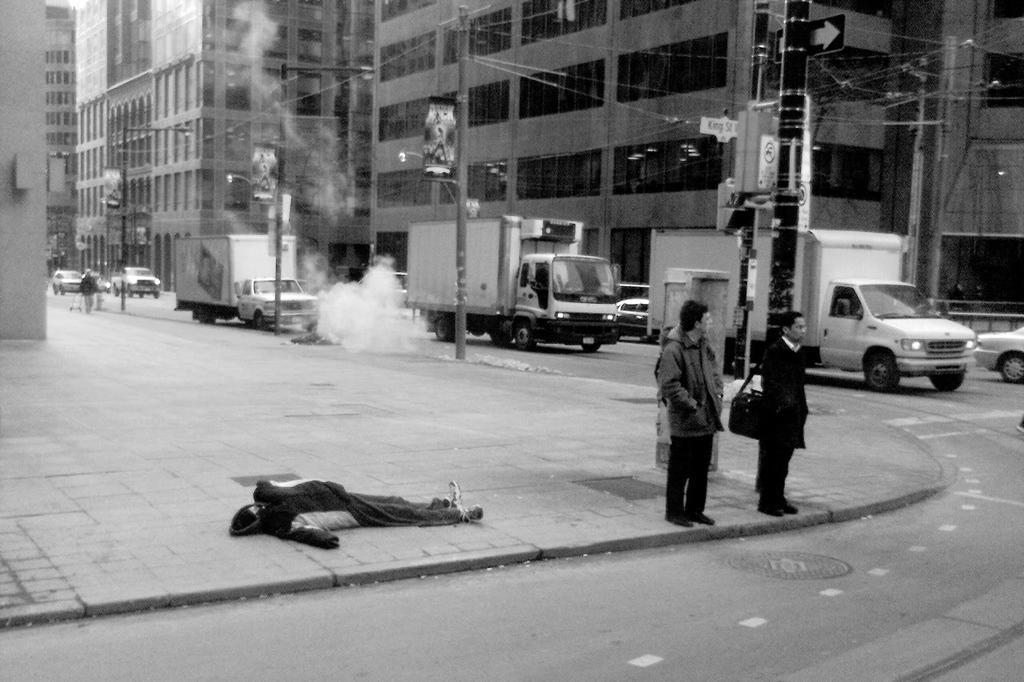Could you give a brief overview of what you see in this image? In the foreground I can see a person is lying on the floor, fleets of vehicles, light poles, wires and a group of people on the road. In the background I can see buildings and windows. This image is taken may be on the road. 